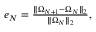Convert formula to latex. <formula><loc_0><loc_0><loc_500><loc_500>\begin{array} { r } { e _ { N } = \frac { \| \Omega _ { N + 1 } - \Omega _ { N } \| _ { 2 } } { \| \Omega _ { N } \| _ { 2 } } , } \end{array}</formula> 